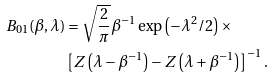<formula> <loc_0><loc_0><loc_500><loc_500>B _ { 0 1 } ( \beta , \lambda ) & = \sqrt { \frac { 2 } { \pi } } \beta ^ { - 1 } \exp \left ( - \lambda ^ { 2 } / 2 \right ) \times \\ & \left [ Z \left ( \lambda - \beta ^ { - 1 } \right ) - Z \left ( \lambda + \beta ^ { - 1 } \right ) \right ] ^ { - 1 } .</formula> 